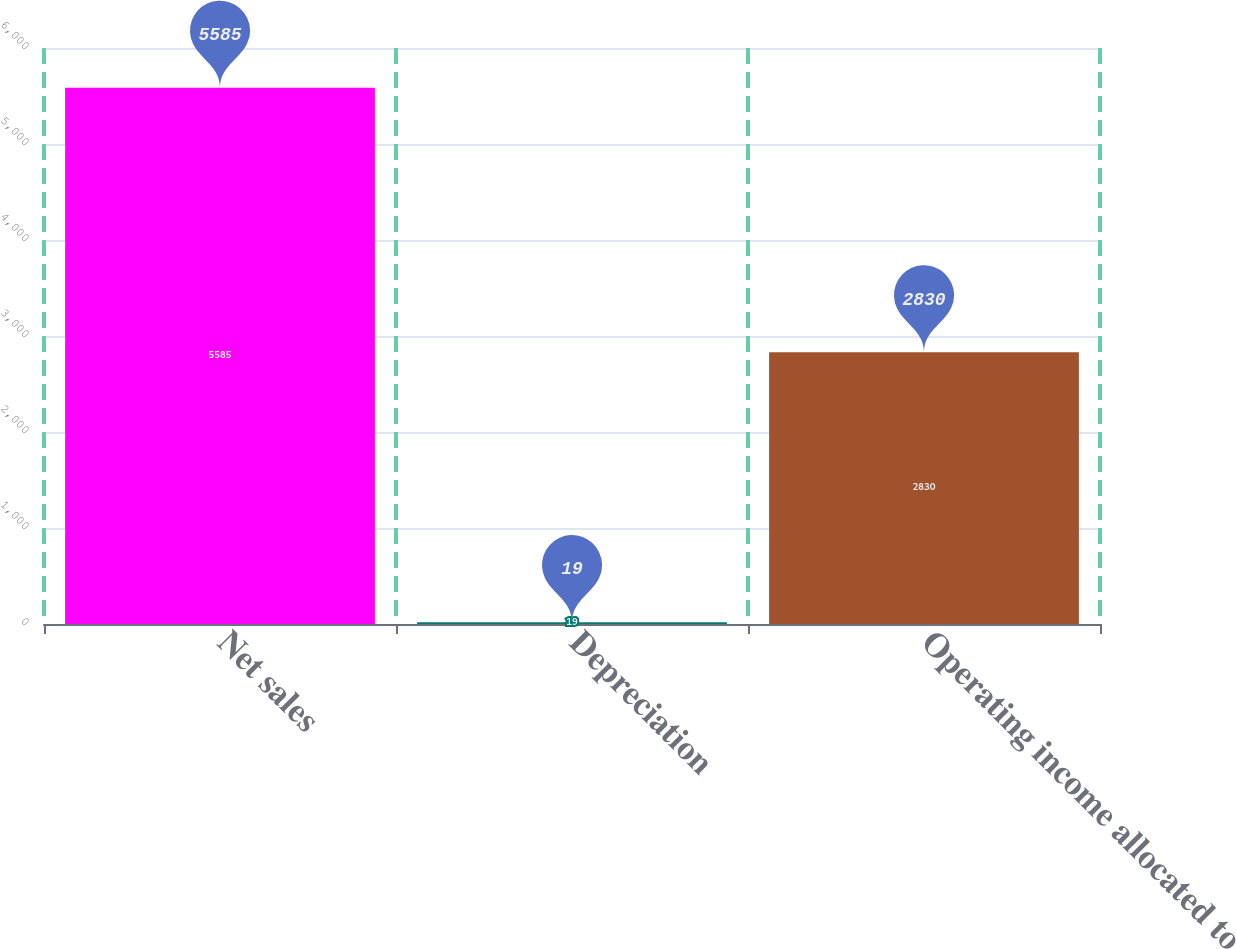Convert chart to OTSL. <chart><loc_0><loc_0><loc_500><loc_500><bar_chart><fcel>Net sales<fcel>Depreciation<fcel>Operating income allocated to<nl><fcel>5585<fcel>19<fcel>2830<nl></chart> 